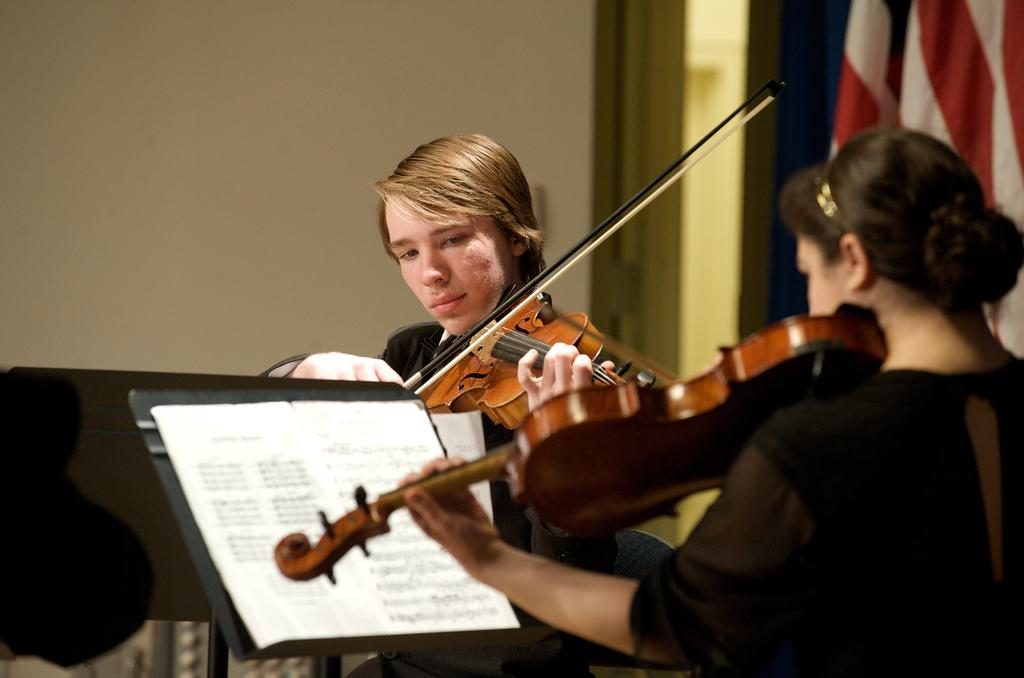How many people are in the image? There are two people in the image. What are the two people doing in the image? The two people are playing the violin. What is in front of the two people? There is a stand in front of the two people. What is on the stand? There are papers on the stand. How many bikes are visible in the image? There are no bikes visible in the image. What type of footwear is the person on the left wearing? There is no information about the footwear of the people in the image. 